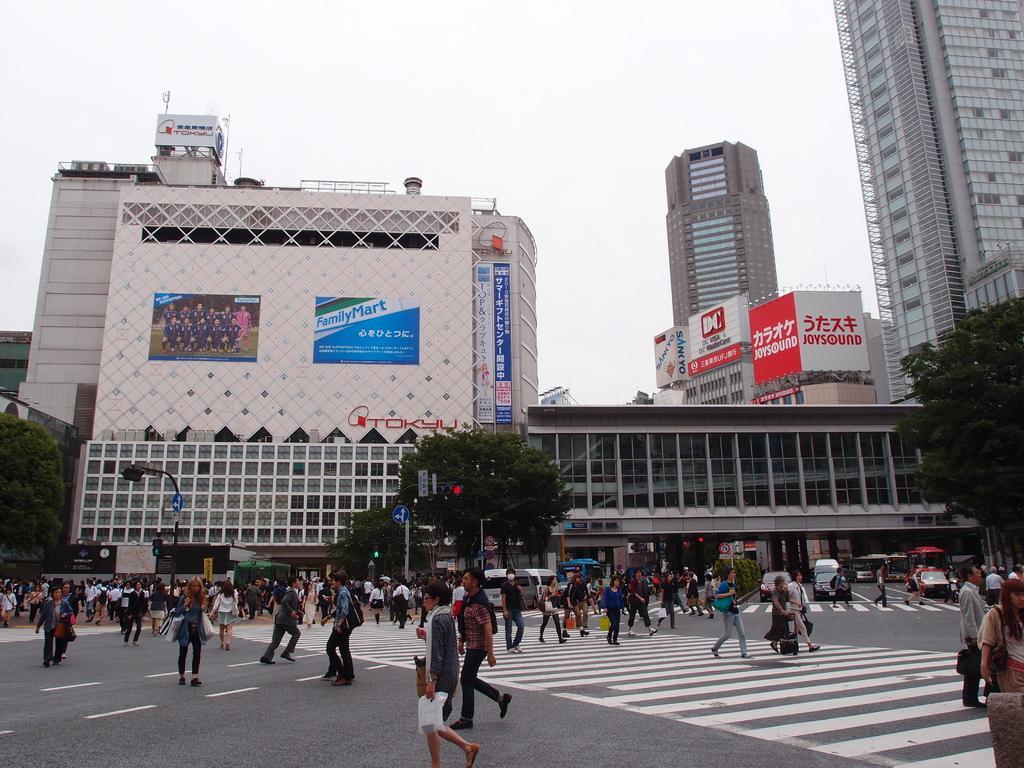Describe this image in one or two sentences. In this picture we can see a group of people walking and vehicles on the road. In the background we can see trees, buildings, plants, banners, poles, some objects and the sky. 